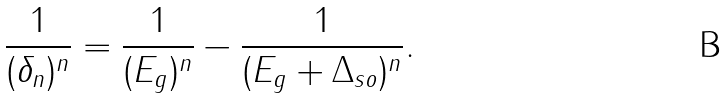Convert formula to latex. <formula><loc_0><loc_0><loc_500><loc_500>\frac { 1 } { ( \delta _ { n } ) ^ { n } } = \frac { 1 } { ( E _ { g } ) ^ { n } } - \frac { 1 } { ( E _ { g } + \Delta _ { s o } ) ^ { n } } .</formula> 